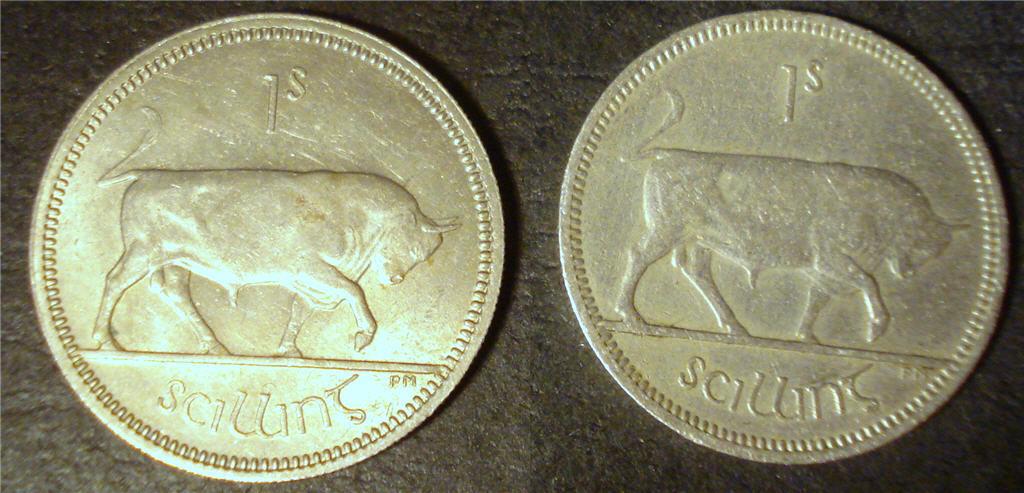What is this coin worth?
Offer a very short reply. 1s. 